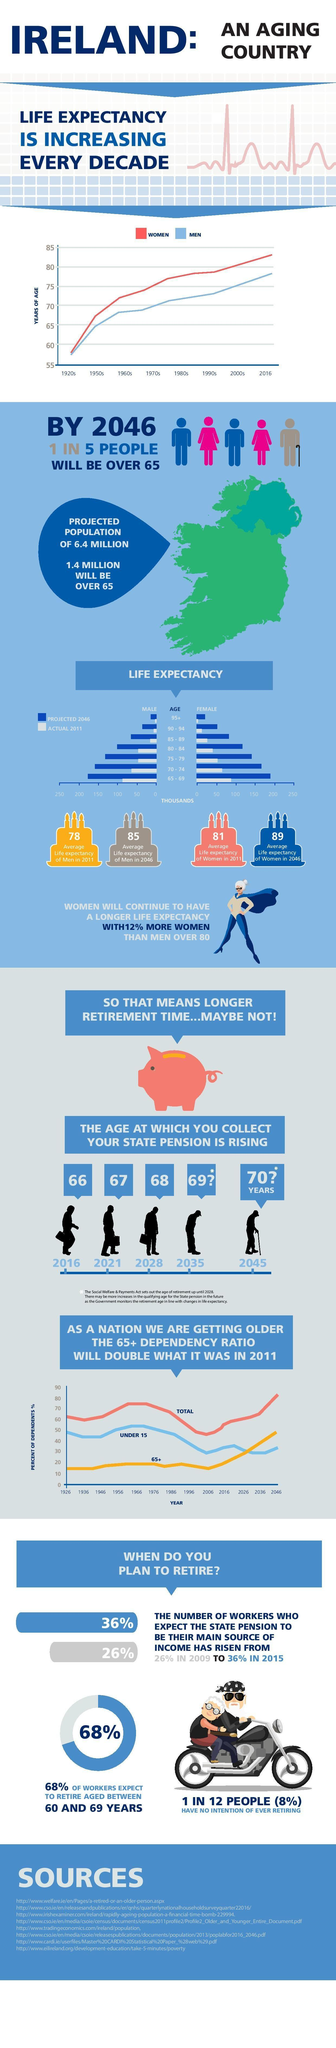Which gender has least life expectancy in 1990s in Ireland?
Answer the question with a short phrase. MEN What percentage of people in Ireland do not have an intention of retiring? 8% What is the pension age in ireland in 2016? 66 What is the projected population of Ireland in 2046? 6.4 million What percentage of workers expect to retire between 60 - 69 years in Ireland? 68% What is the projected pension age in ireland in 2028? 68 What is the average life expectancy of men in 2046 in Ireland? 85 Which gender has more life expectancy in 2016 in Ireland? WOMEN What is the average life expectancy of women in 2011 in Ireland? 81 What percentage of workers expect the state pension to be their main source of income in 2015 in Ireland? 36% 